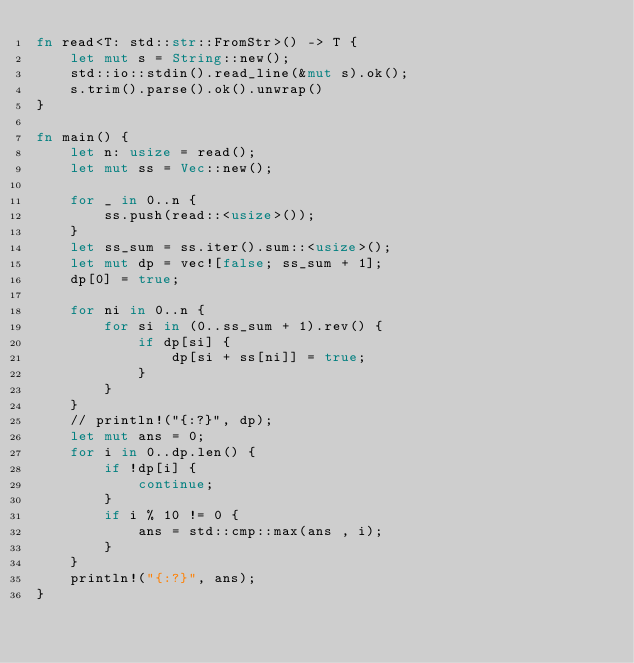Convert code to text. <code><loc_0><loc_0><loc_500><loc_500><_Rust_>fn read<T: std::str::FromStr>() -> T {
    let mut s = String::new();
    std::io::stdin().read_line(&mut s).ok();
    s.trim().parse().ok().unwrap()
}

fn main() {
    let n: usize = read();
    let mut ss = Vec::new();

    for _ in 0..n {
        ss.push(read::<usize>());
    }
    let ss_sum = ss.iter().sum::<usize>();
    let mut dp = vec![false; ss_sum + 1];
    dp[0] = true;

    for ni in 0..n {
        for si in (0..ss_sum + 1).rev() {
            if dp[si] {
                dp[si + ss[ni]] = true;
            }
        }
    }
    // println!("{:?}", dp);
    let mut ans = 0;
    for i in 0..dp.len() {
        if !dp[i] {
            continue;
        }
        if i % 10 != 0 {
            ans = std::cmp::max(ans , i);
        }
    }
    println!("{:?}", ans);
}
</code> 